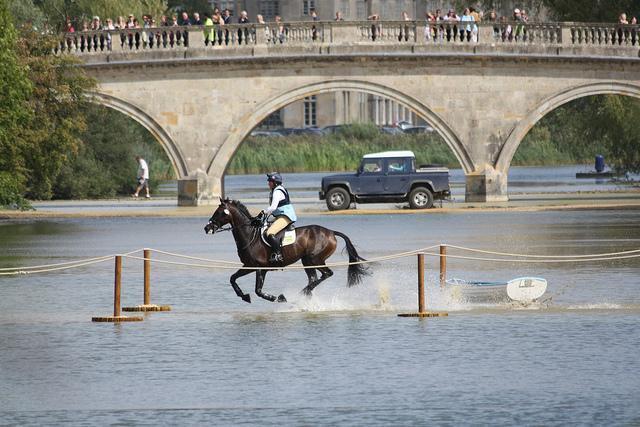How many yellow umbrellas are in this photo?
Give a very brief answer. 0. 